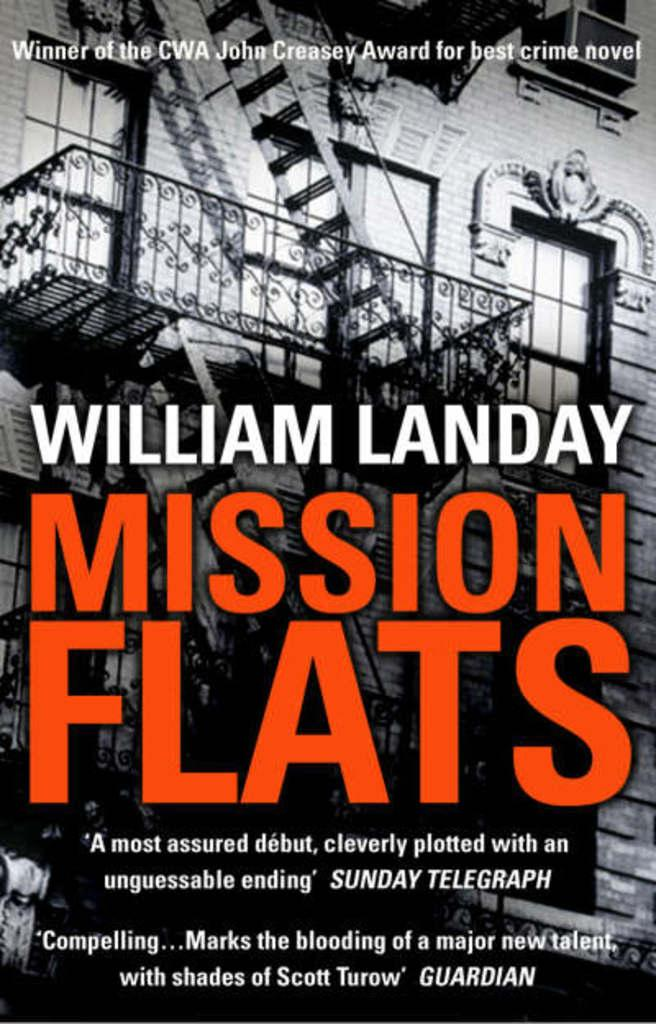What type of structure can be seen in the background of the image? There is a building in the background of the image. What features can be observed on the building? The building has windows, stairs, and a railing. What is visible in the front of the image? There is some text visible in the front of the image. How many trucks are parked in front of the building in the image? There are no trucks visible in the image; it only features a building with windows, stairs, and a railing, along with some text in the front. 